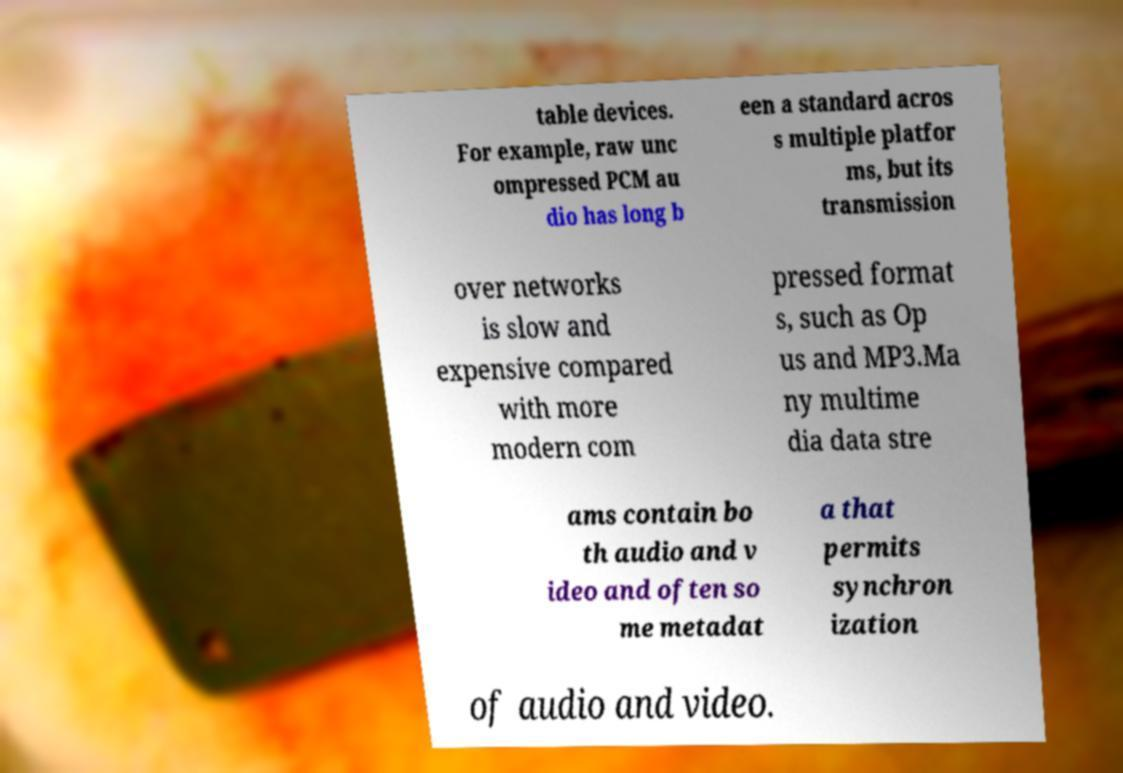Could you extract and type out the text from this image? table devices. For example, raw unc ompressed PCM au dio has long b een a standard acros s multiple platfor ms, but its transmission over networks is slow and expensive compared with more modern com pressed format s, such as Op us and MP3.Ma ny multime dia data stre ams contain bo th audio and v ideo and often so me metadat a that permits synchron ization of audio and video. 